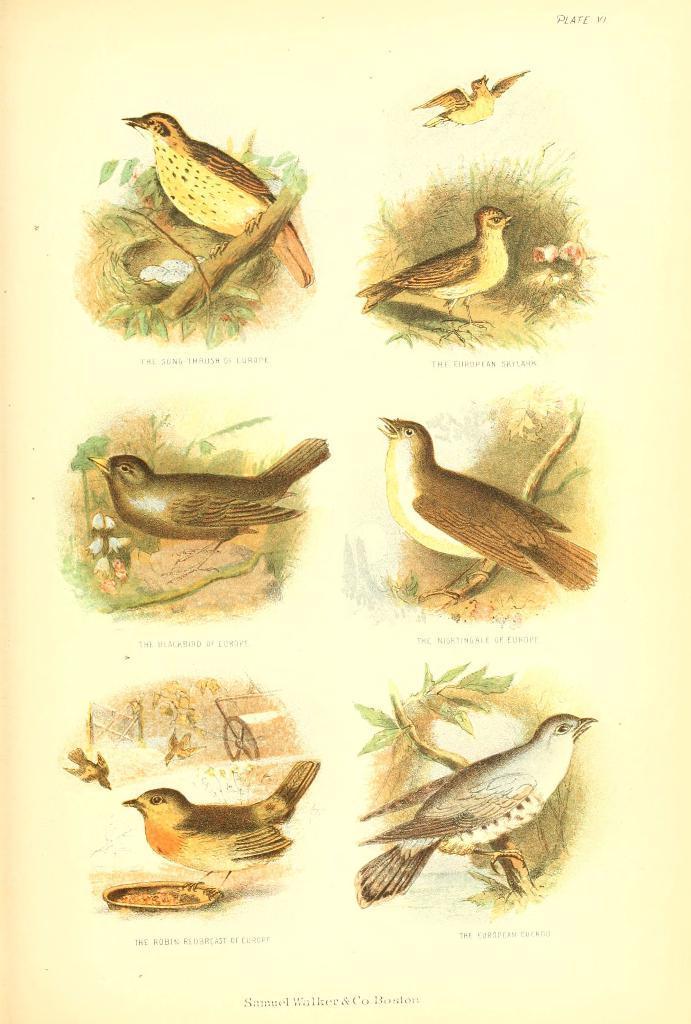Please provide a concise description of this image. This looks like a paper. I can see different types of birds. This looks like a nest with the eggs in it. I can see the letters on the paper. 